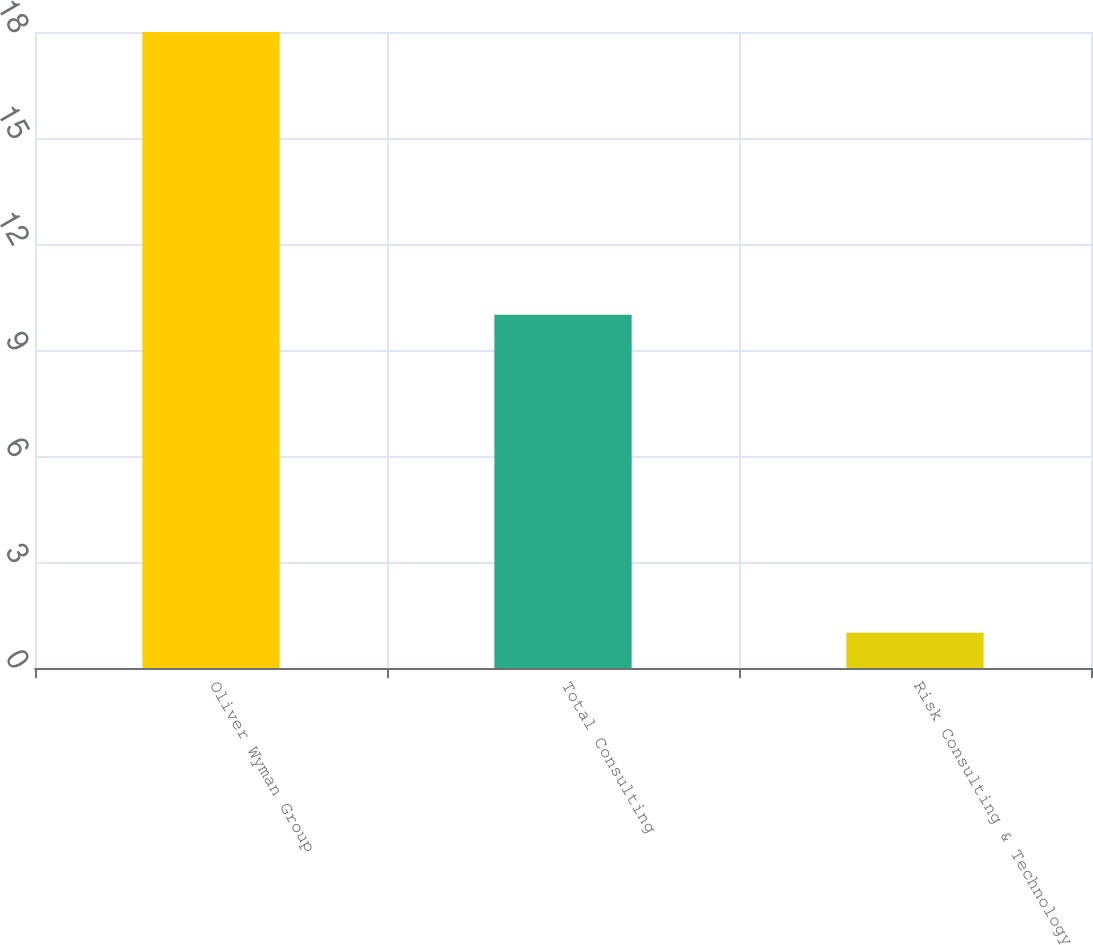Convert chart to OTSL. <chart><loc_0><loc_0><loc_500><loc_500><bar_chart><fcel>Oliver Wyman Group<fcel>Total Consulting<fcel>Risk Consulting & Technology<nl><fcel>18<fcel>10<fcel>1<nl></chart> 